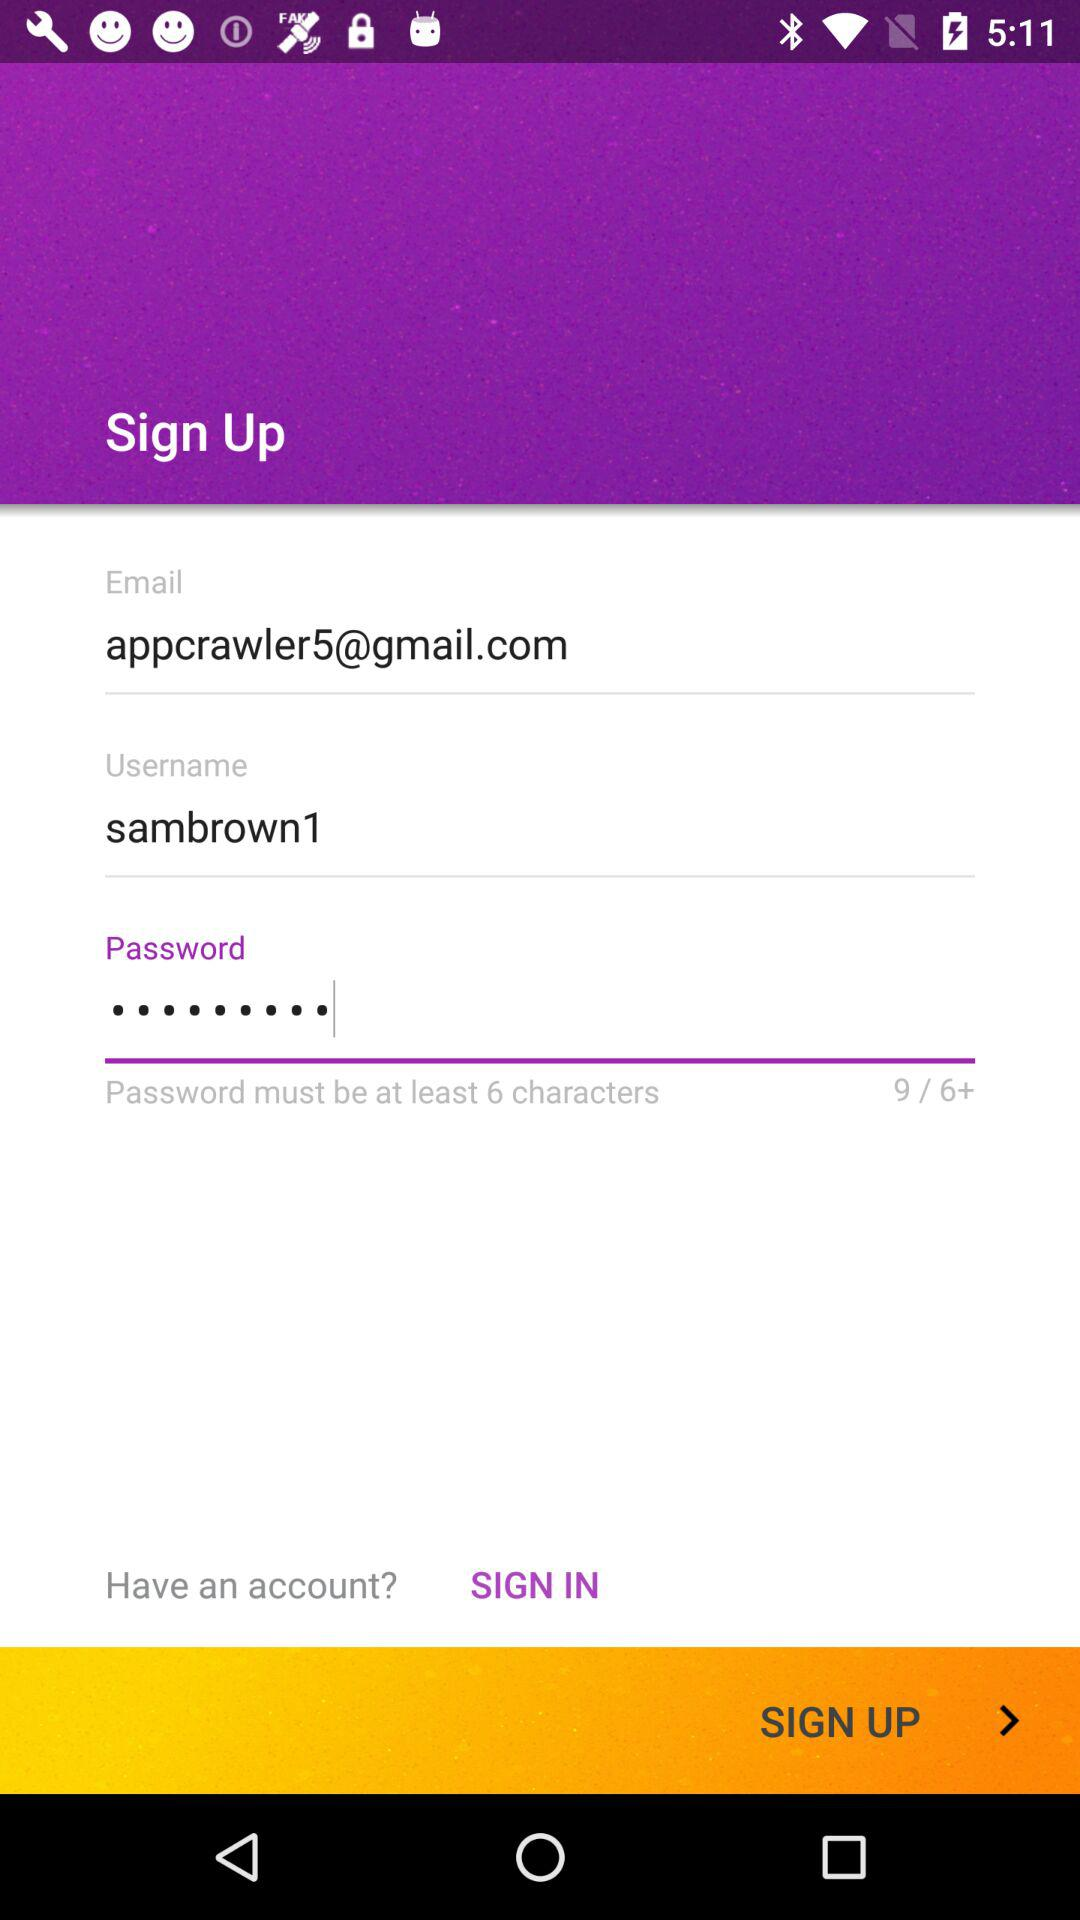What is the email address? The email address is appcrawler5@gmail.com. 